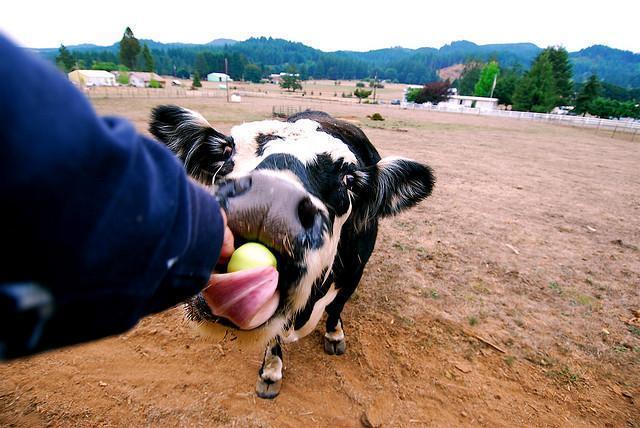How many cats are sitting on the blanket?
Give a very brief answer. 0. 